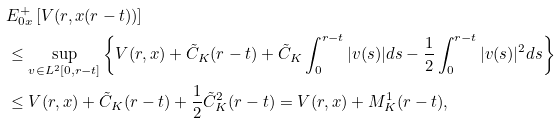Convert formula to latex. <formula><loc_0><loc_0><loc_500><loc_500>& E ^ { + } _ { 0 x } \left [ V ( r , x ( r - t ) ) \right ] \\ & \leq \sup _ { v \in L ^ { 2 } [ 0 , r - t ] } \left \{ V ( r , x ) + \tilde { C } _ { K } ( r - t ) + \tilde { C } _ { K } \int _ { 0 } ^ { r - t } | v ( s ) | d s - \frac { 1 } { 2 } \int _ { 0 } ^ { r - t } | v ( s ) | ^ { 2 } d s \right \} \\ & \leq V ( r , x ) + \tilde { C } _ { K } ( r - t ) + \frac { 1 } { 2 } \tilde { C } _ { K } ^ { 2 } ( r - t ) = V ( r , x ) + { M } _ { K } ^ { 1 } ( r - t ) ,</formula> 